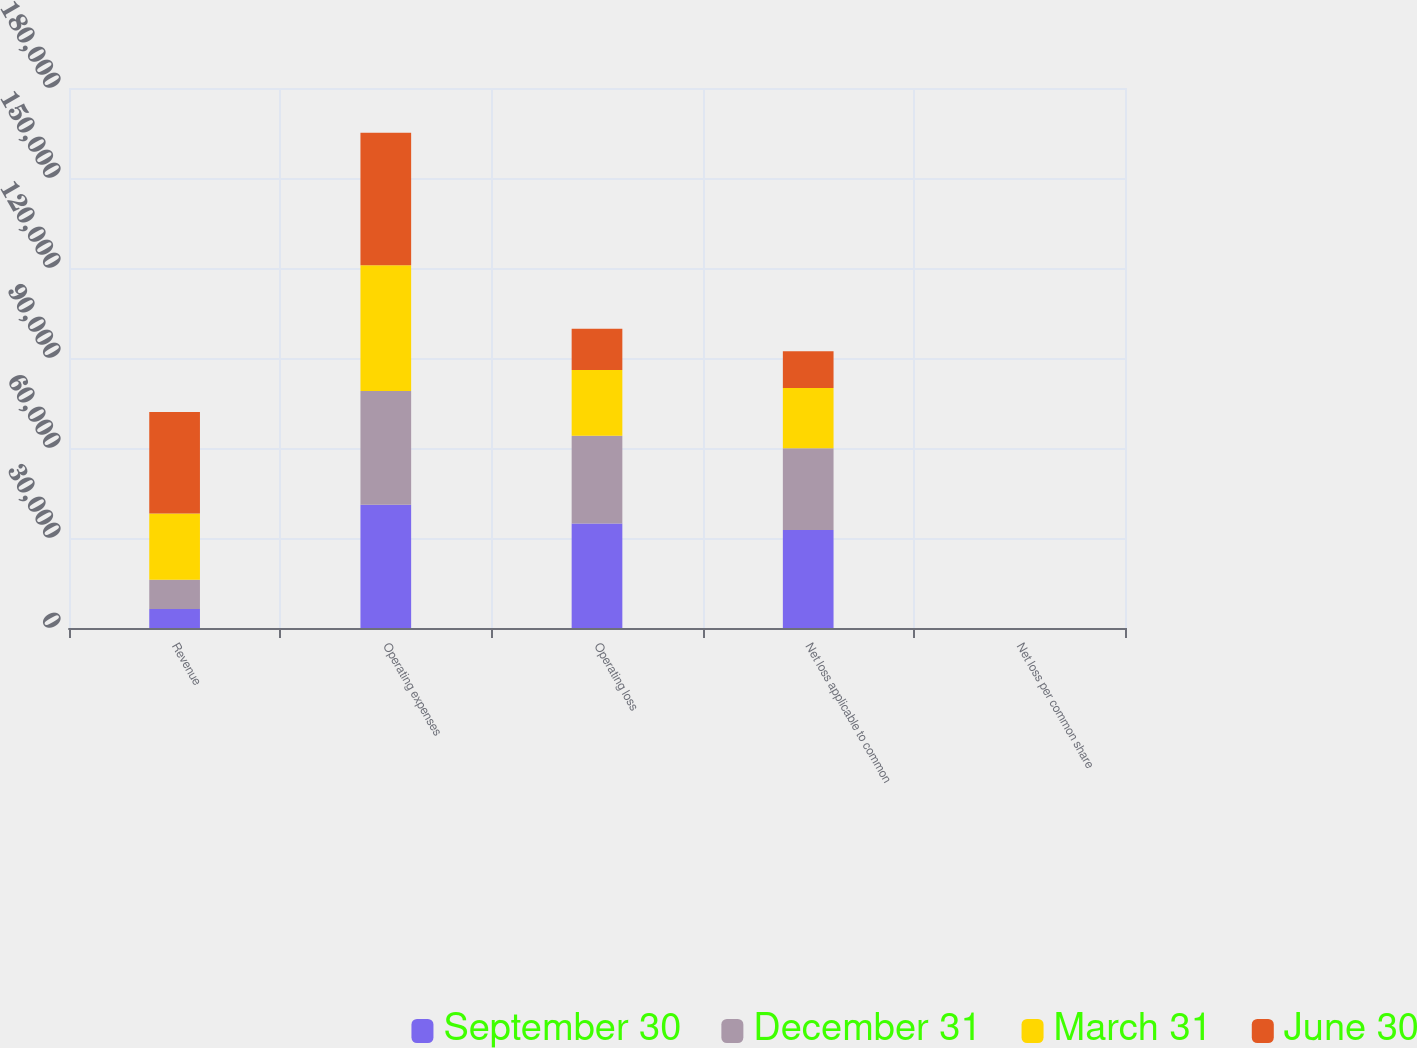<chart> <loc_0><loc_0><loc_500><loc_500><stacked_bar_chart><ecel><fcel>Revenue<fcel>Operating expenses<fcel>Operating loss<fcel>Net loss applicable to common<fcel>Net loss per common share<nl><fcel>September 30<fcel>6317<fcel>41057<fcel>34825<fcel>32693<fcel>0.92<nl><fcel>December 31<fcel>9756<fcel>37983<fcel>29294<fcel>27184<fcel>0.75<nl><fcel>March 31<fcel>22110<fcel>41850<fcel>21894<fcel>20084<fcel>0.55<nl><fcel>June 30<fcel>33858<fcel>44213<fcel>13746<fcel>12330<fcel>0.33<nl></chart> 